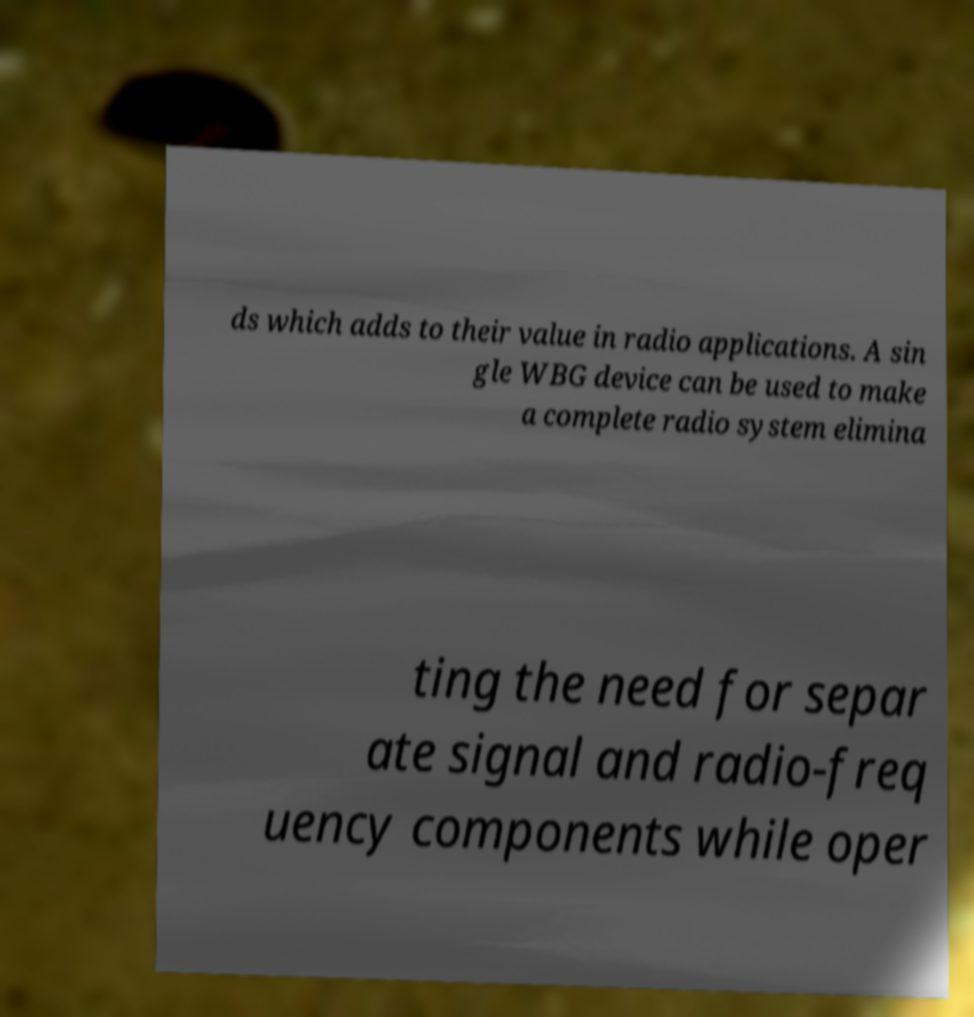Can you read and provide the text displayed in the image?This photo seems to have some interesting text. Can you extract and type it out for me? ds which adds to their value in radio applications. A sin gle WBG device can be used to make a complete radio system elimina ting the need for separ ate signal and radio-freq uency components while oper 